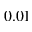<formula> <loc_0><loc_0><loc_500><loc_500>0 . 0 1</formula> 